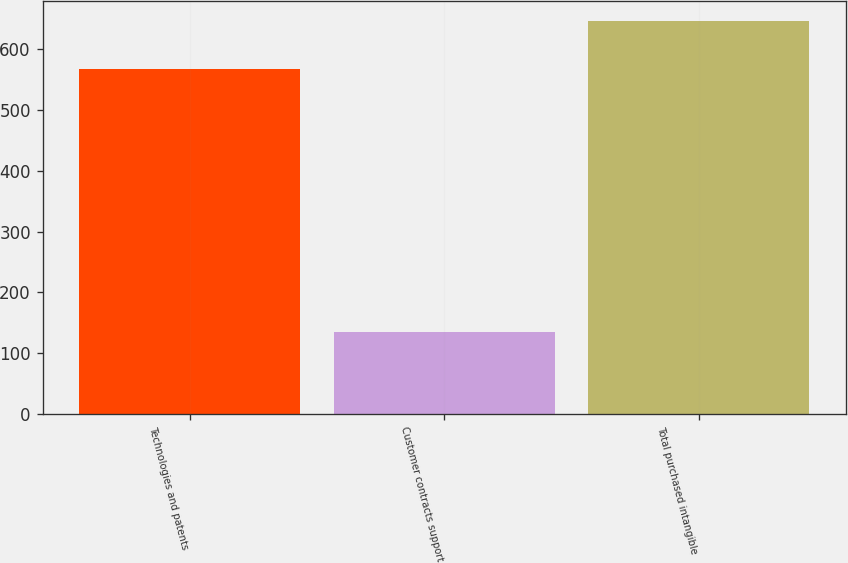<chart> <loc_0><loc_0><loc_500><loc_500><bar_chart><fcel>Technologies and patents<fcel>Customer contracts support<fcel>Total purchased intangible<nl><fcel>567.7<fcel>134.98<fcel>646.9<nl></chart> 